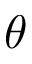Convert formula to latex. <formula><loc_0><loc_0><loc_500><loc_500>\theta</formula> 